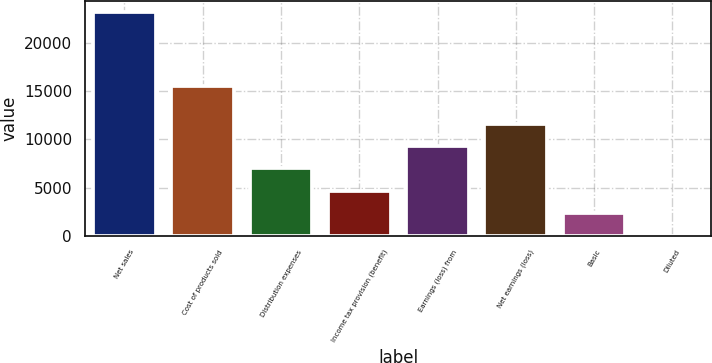Convert chart. <chart><loc_0><loc_0><loc_500><loc_500><bar_chart><fcel>Net sales<fcel>Cost of products sold<fcel>Distribution expenses<fcel>Income tax provision (benefit)<fcel>Earnings (loss) from<fcel>Net earnings (loss)<fcel>Basic<fcel>Diluted<nl><fcel>23274<fcel>15535<fcel>6985.6<fcel>4658.68<fcel>9312.52<fcel>11639.4<fcel>2331.76<fcel>4.84<nl></chart> 